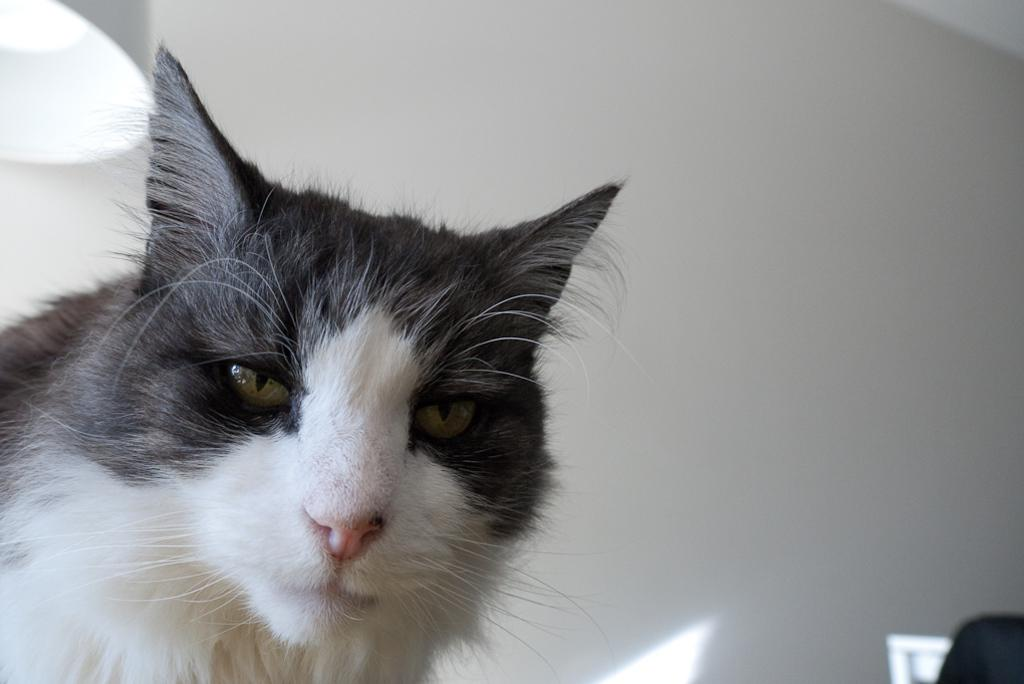What type of animal is in the image? There is a cat in the image. Can you describe the color pattern of the cat? The cat has a white and black color combination. Where is the cat located in relation to the light? The cat is near a light. What is visible in the background of the image? There is a white wall in the background of the image. What type of weather can be seen in the image? There is no indication of weather in the image, as it is focused on the cat and its surroundings. Can you tell me how many grapes are on the cat's tail in the image? There are no grapes present in the image, and the cat's tail is not visible. 